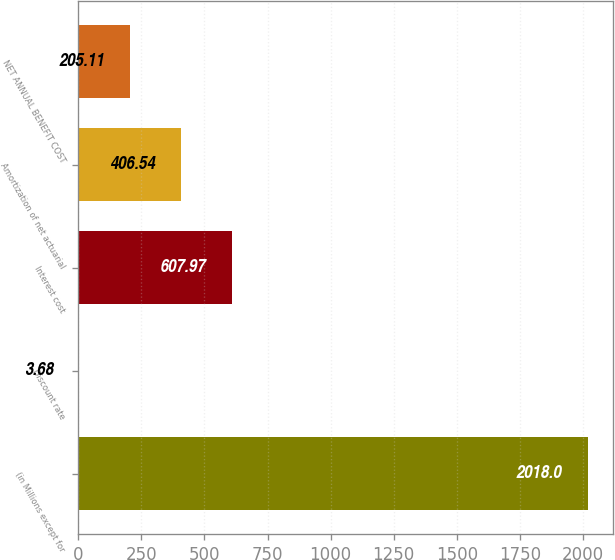Convert chart to OTSL. <chart><loc_0><loc_0><loc_500><loc_500><bar_chart><fcel>(in Millions except for<fcel>Discount rate<fcel>Interest cost<fcel>Amortization of net actuarial<fcel>NET ANNUAL BENEFIT COST<nl><fcel>2018<fcel>3.68<fcel>607.97<fcel>406.54<fcel>205.11<nl></chart> 